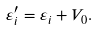Convert formula to latex. <formula><loc_0><loc_0><loc_500><loc_500>\varepsilon ^ { \prime } _ { i } = \varepsilon _ { i } + V _ { 0 } .</formula> 